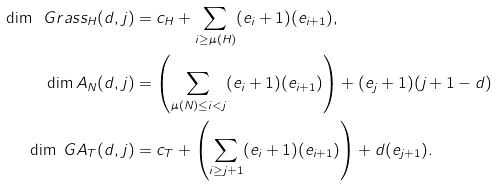Convert formula to latex. <formula><loc_0><loc_0><loc_500><loc_500>\dim \ G r a s s _ { H } ( d , j ) & = c _ { H } + \sum _ { i \geq \mu ( H ) } ( e _ { i } + 1 ) ( e _ { i + 1 } ) , \\ \dim \L A _ { N } ( d , j ) & = \left ( \sum _ { \mu ( N ) \leq i < j } ( e _ { i } + 1 ) ( e _ { i + 1 } ) \right ) + ( e _ { j } + 1 ) ( j + 1 - d ) \\ \dim \ G A _ { T } ( d , j ) & = c _ { T } + \left ( \sum _ { i \geq j + 1 } ( e _ { i } + 1 ) ( e _ { i + 1 } ) \right ) + d ( e _ { j + 1 } ) .</formula> 